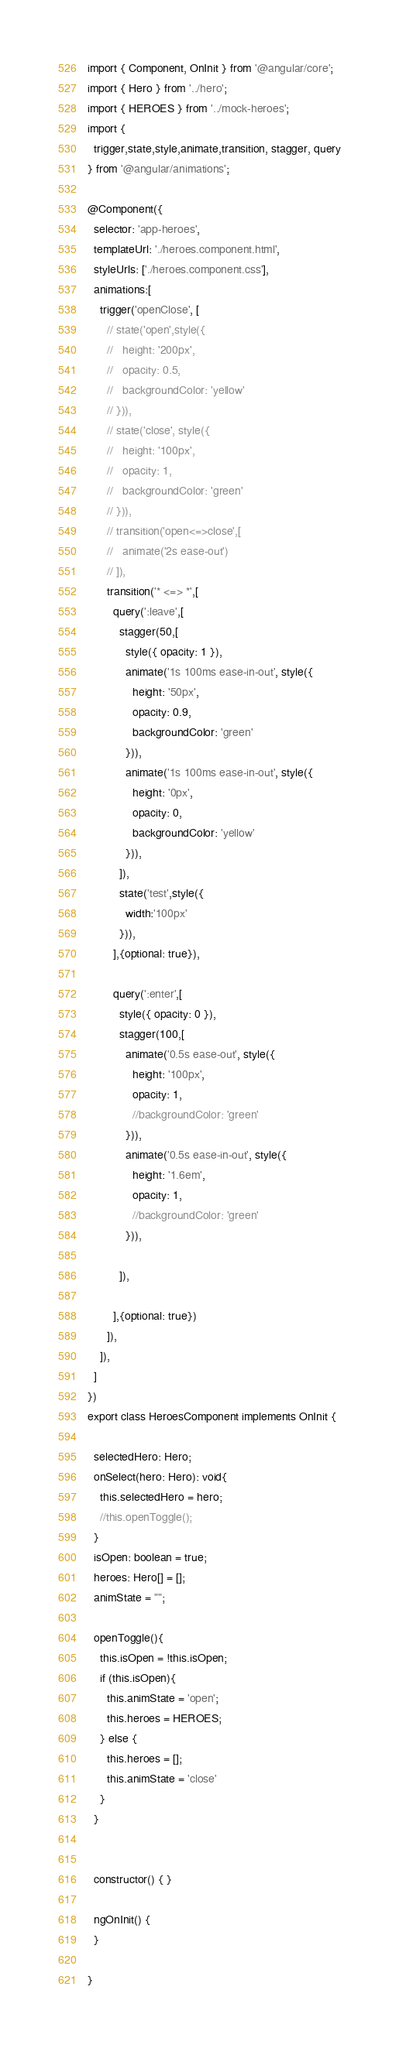Convert code to text. <code><loc_0><loc_0><loc_500><loc_500><_TypeScript_>import { Component, OnInit } from '@angular/core';
import { Hero } from '../hero';
import { HEROES } from '../mock-heroes';
import {
  trigger,state,style,animate,transition, stagger, query
} from '@angular/animations';

@Component({
  selector: 'app-heroes',
  templateUrl: './heroes.component.html',
  styleUrls: ['./heroes.component.css'],
  animations:[
    trigger('openClose', [
      // state('open',style({
      //   height: '200px',
      //   opacity: 0.5,
      //   backgroundColor: 'yellow'
      // })),
      // state('close', style({
      //   height: '100px',
      //   opacity: 1,
      //   backgroundColor: 'green'
      // })),
      // transition('open<=>close',[
      //   animate('2s ease-out')
      // ]),
      transition('* <=> *',[
        query(':leave',[
          stagger(50,[
            style({ opacity: 1 }),
            animate('1s 100ms ease-in-out', style({
              height: '50px',
              opacity: 0.9,
              backgroundColor: 'green'
            })),
            animate('1s 100ms ease-in-out', style({
              height: '0px',
              opacity: 0,
              backgroundColor: 'yellow'
            })),
          ]),
          state('test',style({
            width:'100px'
          })),
        ],{optional: true}),
        
        query(':enter',[
          style({ opacity: 0 }),
          stagger(100,[
            animate('0.5s ease-out', style({
              height: '100px',
              opacity: 1,
              //backgroundColor: 'green'
            })),
            animate('0.5s ease-in-out', style({
              height: '1.6em',
              opacity: 1,
              //backgroundColor: 'green'
            })),

          ]),

        ],{optional: true})
      ]),
    ]),
  ]
})
export class HeroesComponent implements OnInit {

  selectedHero: Hero;
  onSelect(hero: Hero): void{
    this.selectedHero = hero;
    //this.openToggle();
  }
  isOpen: boolean = true;
  heroes: Hero[] = [];
  animState = "";

  openToggle(){
    this.isOpen = !this.isOpen;
    if (this.isOpen){
      this.animState = 'open';
      this.heroes = HEROES;
    } else {
      this.heroes = [];
      this.animState = 'close'
    }
  }


  constructor() { }

  ngOnInit() {
  }

}

</code> 